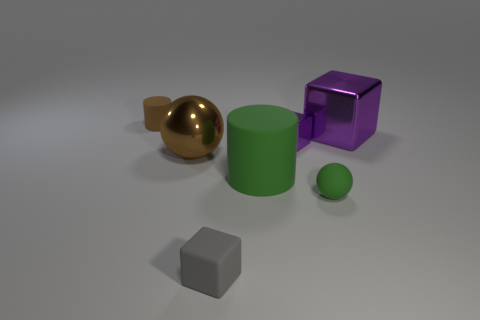Add 1 tiny purple metallic blocks. How many objects exist? 8 Subtract all blocks. How many objects are left? 4 Subtract all yellow matte balls. Subtract all blocks. How many objects are left? 4 Add 1 large green things. How many large green things are left? 2 Add 4 matte cylinders. How many matte cylinders exist? 6 Subtract 0 cyan cylinders. How many objects are left? 7 